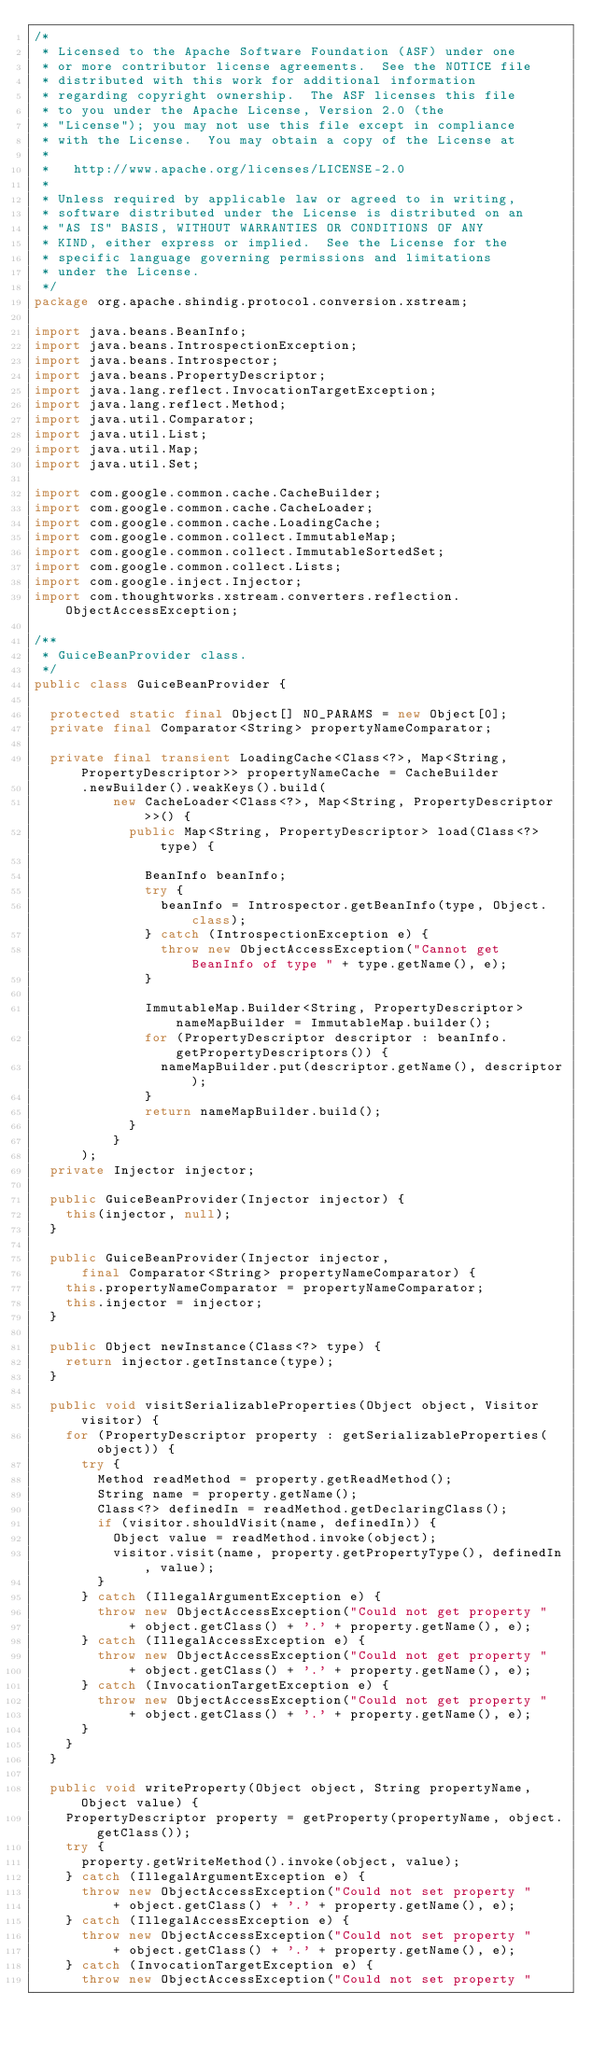Convert code to text. <code><loc_0><loc_0><loc_500><loc_500><_Java_>/*
 * Licensed to the Apache Software Foundation (ASF) under one
 * or more contributor license agreements.  See the NOTICE file
 * distributed with this work for additional information
 * regarding copyright ownership.  The ASF licenses this file
 * to you under the Apache License, Version 2.0 (the
 * "License"); you may not use this file except in compliance
 * with the License.  You may obtain a copy of the License at
 *
 *   http://www.apache.org/licenses/LICENSE-2.0
 *
 * Unless required by applicable law or agreed to in writing,
 * software distributed under the License is distributed on an
 * "AS IS" BASIS, WITHOUT WARRANTIES OR CONDITIONS OF ANY
 * KIND, either express or implied.  See the License for the
 * specific language governing permissions and limitations
 * under the License.
 */
package org.apache.shindig.protocol.conversion.xstream;

import java.beans.BeanInfo;
import java.beans.IntrospectionException;
import java.beans.Introspector;
import java.beans.PropertyDescriptor;
import java.lang.reflect.InvocationTargetException;
import java.lang.reflect.Method;
import java.util.Comparator;
import java.util.List;
import java.util.Map;
import java.util.Set;

import com.google.common.cache.CacheBuilder;
import com.google.common.cache.CacheLoader;
import com.google.common.cache.LoadingCache;
import com.google.common.collect.ImmutableMap;
import com.google.common.collect.ImmutableSortedSet;
import com.google.common.collect.Lists;
import com.google.inject.Injector;
import com.thoughtworks.xstream.converters.reflection.ObjectAccessException;

/**
 * GuiceBeanProvider class.
 */
public class GuiceBeanProvider {

  protected static final Object[] NO_PARAMS = new Object[0];
  private final Comparator<String> propertyNameComparator;

  private final transient LoadingCache<Class<?>, Map<String, PropertyDescriptor>> propertyNameCache = CacheBuilder
      .newBuilder().weakKeys().build(
          new CacheLoader<Class<?>, Map<String, PropertyDescriptor>>() {
            public Map<String, PropertyDescriptor> load(Class<?> type) {

              BeanInfo beanInfo;
              try {
                beanInfo = Introspector.getBeanInfo(type, Object.class);
              } catch (IntrospectionException e) {
                throw new ObjectAccessException("Cannot get BeanInfo of type " + type.getName(), e);
              }

              ImmutableMap.Builder<String, PropertyDescriptor> nameMapBuilder = ImmutableMap.builder();
              for (PropertyDescriptor descriptor : beanInfo.getPropertyDescriptors()) {
                nameMapBuilder.put(descriptor.getName(), descriptor);
              }
              return nameMapBuilder.build();
            }
          }
      );
  private Injector injector;

  public GuiceBeanProvider(Injector injector) {
    this(injector, null);
  }

  public GuiceBeanProvider(Injector injector,
      final Comparator<String> propertyNameComparator) {
    this.propertyNameComparator = propertyNameComparator;
    this.injector = injector;
  }

  public Object newInstance(Class<?> type) {
    return injector.getInstance(type);
  }

  public void visitSerializableProperties(Object object, Visitor visitor) {
    for (PropertyDescriptor property : getSerializableProperties(object)) {
      try {
        Method readMethod = property.getReadMethod();
        String name = property.getName();
        Class<?> definedIn = readMethod.getDeclaringClass();
        if (visitor.shouldVisit(name, definedIn)) {
          Object value = readMethod.invoke(object);
          visitor.visit(name, property.getPropertyType(), definedIn, value);
        }
      } catch (IllegalArgumentException e) {
        throw new ObjectAccessException("Could not get property "
            + object.getClass() + '.' + property.getName(), e);
      } catch (IllegalAccessException e) {
        throw new ObjectAccessException("Could not get property "
            + object.getClass() + '.' + property.getName(), e);
      } catch (InvocationTargetException e) {
        throw new ObjectAccessException("Could not get property "
            + object.getClass() + '.' + property.getName(), e);
      }
    }
  }

  public void writeProperty(Object object, String propertyName, Object value) {
    PropertyDescriptor property = getProperty(propertyName, object.getClass());
    try {
      property.getWriteMethod().invoke(object, value);
    } catch (IllegalArgumentException e) {
      throw new ObjectAccessException("Could not set property "
          + object.getClass() + '.' + property.getName(), e);
    } catch (IllegalAccessException e) {
      throw new ObjectAccessException("Could not set property "
          + object.getClass() + '.' + property.getName(), e);
    } catch (InvocationTargetException e) {
      throw new ObjectAccessException("Could not set property "</code> 